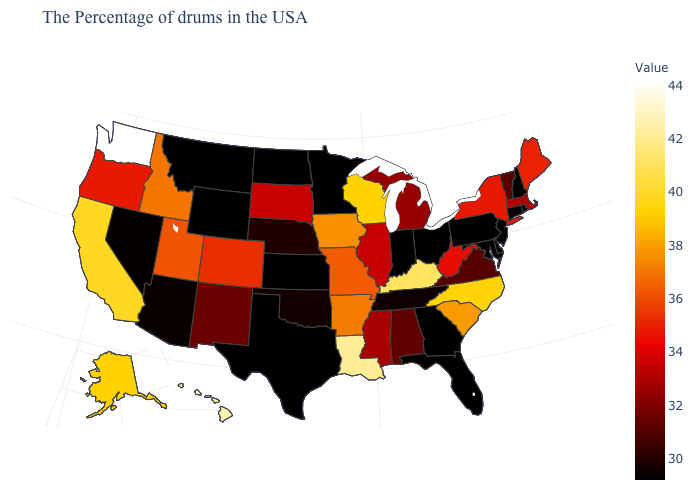Which states hav the highest value in the South?
Answer briefly. Louisiana. Among the states that border New Jersey , which have the highest value?
Answer briefly. New York. Which states hav the highest value in the Northeast?
Write a very short answer. Maine. Does New Hampshire have the lowest value in the USA?
Write a very short answer. Yes. Is the legend a continuous bar?
Concise answer only. Yes. Does the map have missing data?
Short answer required. No. Does Kansas have the lowest value in the MidWest?
Concise answer only. Yes. Which states have the highest value in the USA?
Be succinct. Washington. Which states hav the highest value in the South?
Give a very brief answer. Louisiana. Which states hav the highest value in the West?
Be succinct. Washington. 